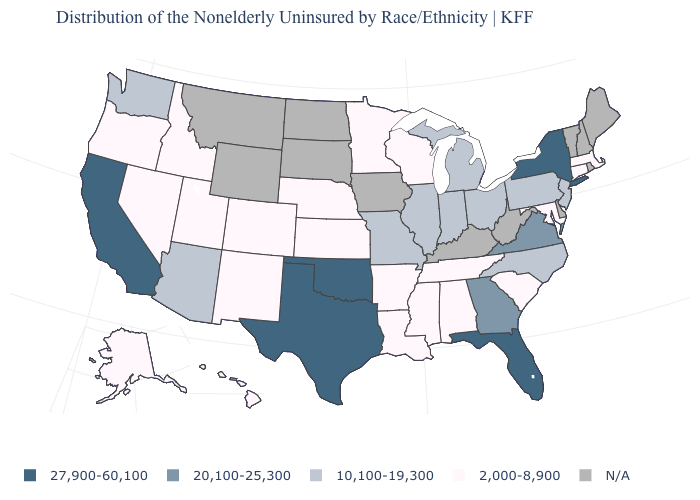Name the states that have a value in the range 2,000-8,900?
Quick response, please. Alabama, Alaska, Arkansas, Colorado, Connecticut, Hawaii, Idaho, Kansas, Louisiana, Maryland, Massachusetts, Minnesota, Mississippi, Nebraska, Nevada, New Mexico, Oregon, South Carolina, Tennessee, Utah, Wisconsin. What is the value of Maine?
Answer briefly. N/A. Which states hav the highest value in the MidWest?
Concise answer only. Illinois, Indiana, Michigan, Missouri, Ohio. How many symbols are there in the legend?
Quick response, please. 5. What is the value of Michigan?
Give a very brief answer. 10,100-19,300. What is the lowest value in states that border Ohio?
Concise answer only. 10,100-19,300. What is the lowest value in the USA?
Give a very brief answer. 2,000-8,900. What is the value of Missouri?
Keep it brief. 10,100-19,300. Does the first symbol in the legend represent the smallest category?
Write a very short answer. No. What is the value of Maryland?
Be succinct. 2,000-8,900. Among the states that border Maryland , which have the highest value?
Answer briefly. Virginia. Does the first symbol in the legend represent the smallest category?
Quick response, please. No. Name the states that have a value in the range 27,900-60,100?
Give a very brief answer. California, Florida, New York, Oklahoma, Texas. Does New Jersey have the highest value in the Northeast?
Keep it brief. No. Among the states that border Arkansas , which have the highest value?
Answer briefly. Oklahoma, Texas. 